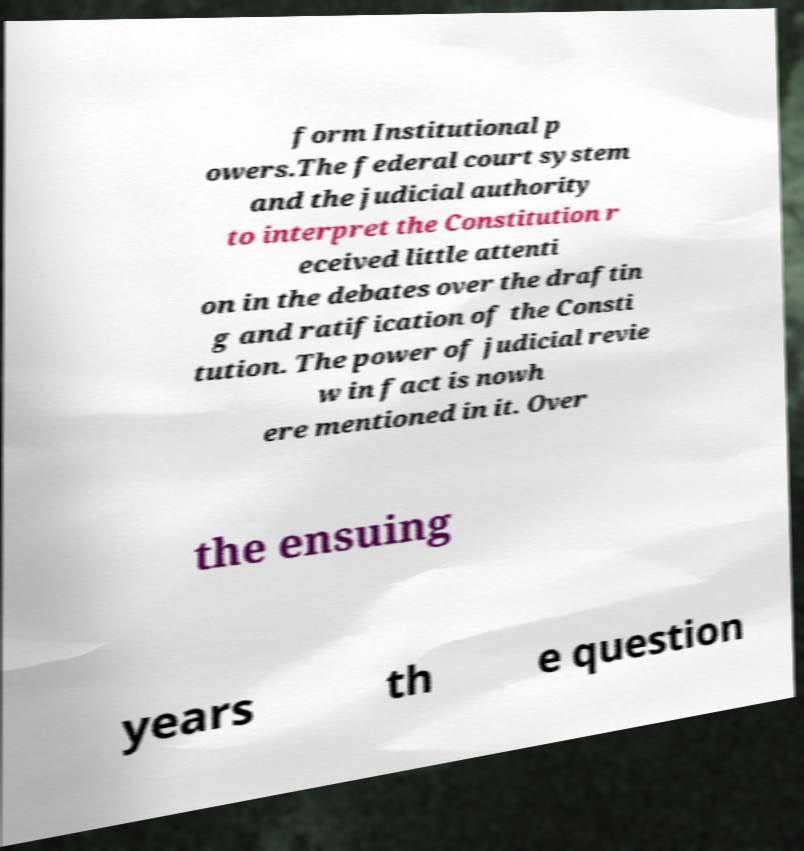Could you assist in decoding the text presented in this image and type it out clearly? form Institutional p owers.The federal court system and the judicial authority to interpret the Constitution r eceived little attenti on in the debates over the draftin g and ratification of the Consti tution. The power of judicial revie w in fact is nowh ere mentioned in it. Over the ensuing years th e question 